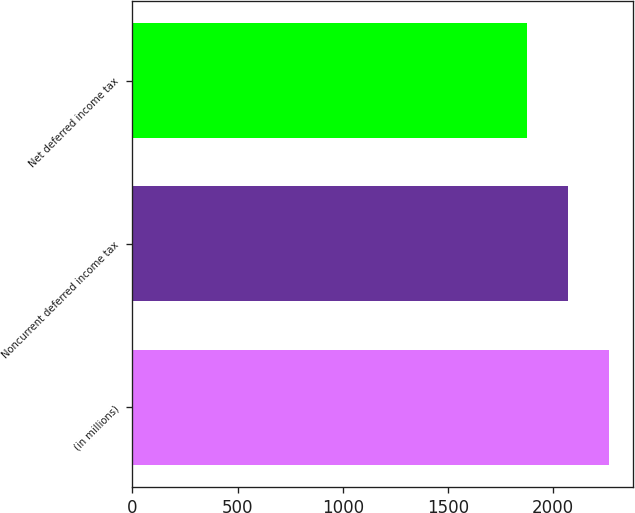<chart> <loc_0><loc_0><loc_500><loc_500><bar_chart><fcel>(in millions)<fcel>Noncurrent deferred income tax<fcel>Net deferred income tax<nl><fcel>2264.8<fcel>2070.4<fcel>1876<nl></chart> 